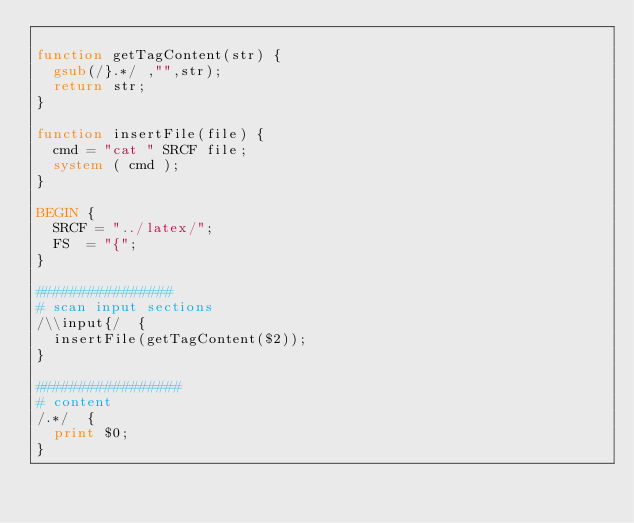Convert code to text. <code><loc_0><loc_0><loc_500><loc_500><_Awk_>
function getTagContent(str) {
	gsub(/}.*/ ,"",str);
	return str;
}

function insertFile(file) {
	cmd = "cat " SRCF file;
	system ( cmd );
}

BEGIN {
	SRCF = "../latex/";
	FS  = "{";
}

################ 
# scan input sections
/\\input{/ 	{
	insertFile(getTagContent($2));
}

################# 
# content
/.*/ 	{
	print $0; 
}
</code> 